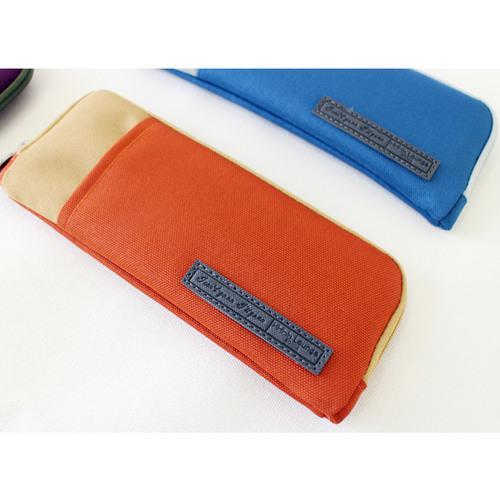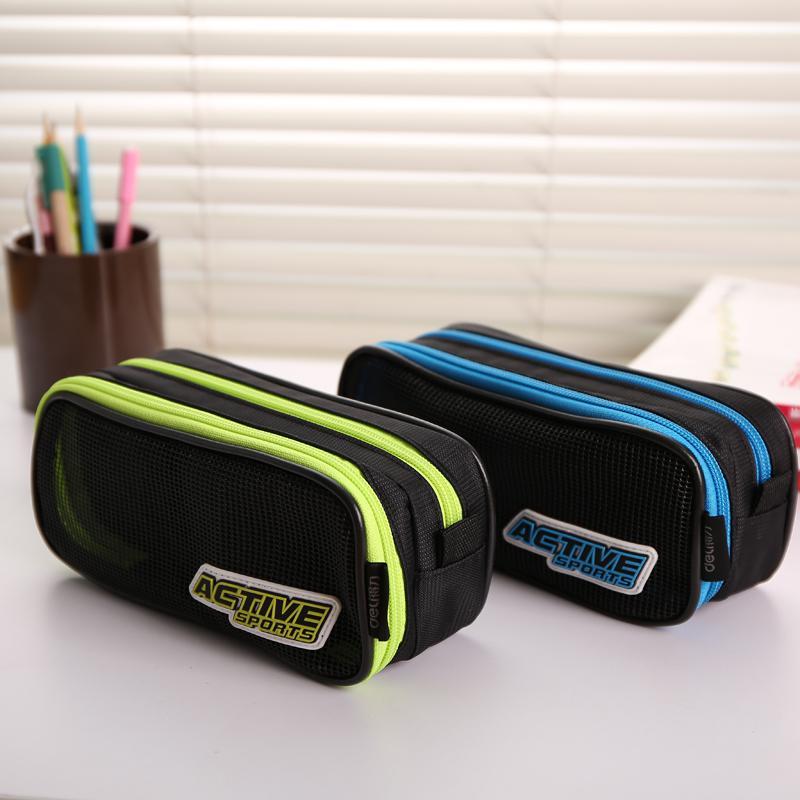The first image is the image on the left, the second image is the image on the right. Given the left and right images, does the statement "Each image contains a single closed pencil case, and at least one case is a solid color with contrasting zipper." hold true? Answer yes or no. No. 